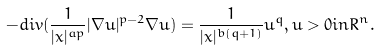Convert formula to latex. <formula><loc_0><loc_0><loc_500><loc_500>- d i v ( \frac { 1 } { | x | ^ { a p } } | \nabla u | ^ { p - 2 } \nabla u ) = \frac { 1 } { | x | ^ { b ( q + 1 ) } } u ^ { q } , u > 0 i n R ^ { n } .</formula> 